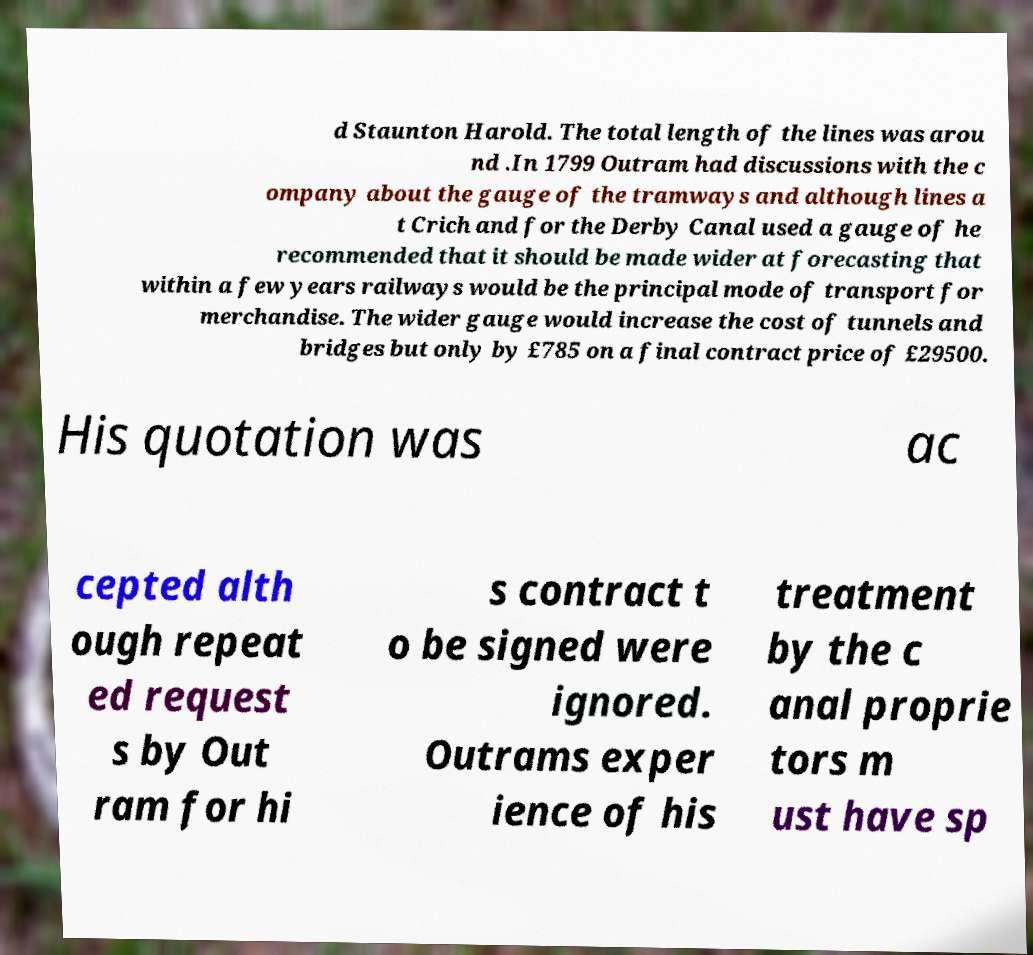Please read and relay the text visible in this image. What does it say? d Staunton Harold. The total length of the lines was arou nd .In 1799 Outram had discussions with the c ompany about the gauge of the tramways and although lines a t Crich and for the Derby Canal used a gauge of he recommended that it should be made wider at forecasting that within a few years railways would be the principal mode of transport for merchandise. The wider gauge would increase the cost of tunnels and bridges but only by £785 on a final contract price of £29500. His quotation was ac cepted alth ough repeat ed request s by Out ram for hi s contract t o be signed were ignored. Outrams exper ience of his treatment by the c anal proprie tors m ust have sp 